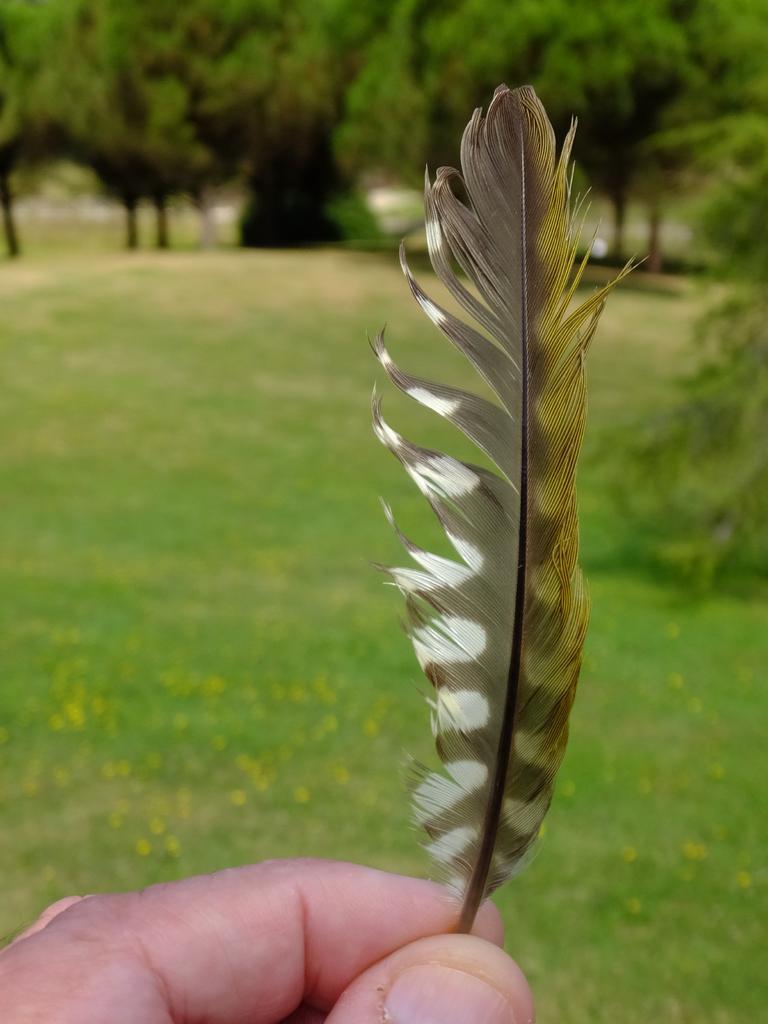How would you summarize this image in a sentence or two? In this image, we can see human fingers with feather. Background there is a blur view. Here we can see grass, plants and trees. 